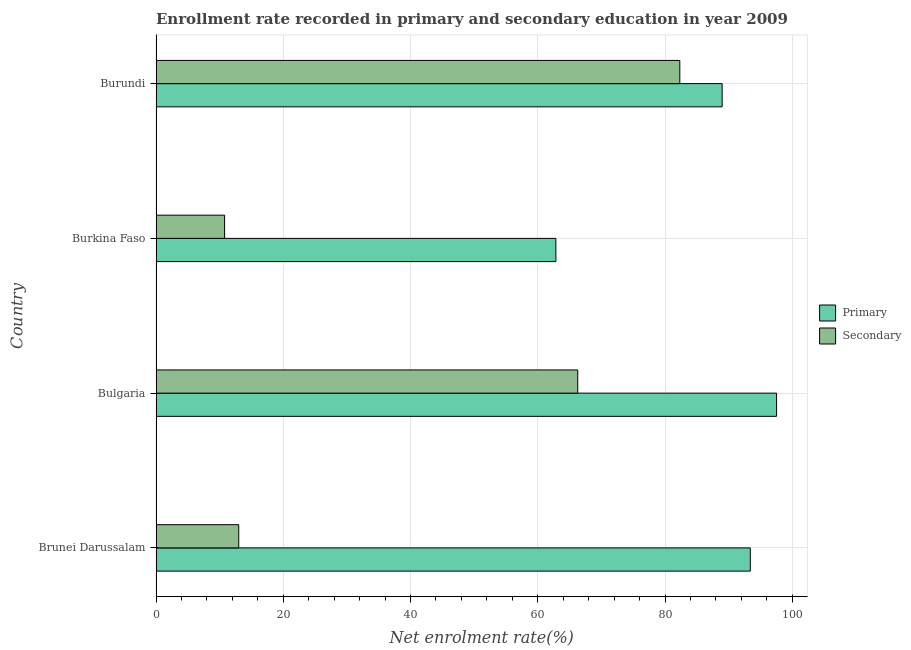How many groups of bars are there?
Ensure brevity in your answer.  4. Are the number of bars per tick equal to the number of legend labels?
Your answer should be compact. Yes. How many bars are there on the 4th tick from the top?
Provide a succinct answer. 2. What is the label of the 1st group of bars from the top?
Your answer should be very brief. Burundi. What is the enrollment rate in primary education in Burundi?
Offer a terse response. 88.98. Across all countries, what is the maximum enrollment rate in primary education?
Give a very brief answer. 97.53. Across all countries, what is the minimum enrollment rate in secondary education?
Provide a short and direct response. 10.78. In which country was the enrollment rate in primary education minimum?
Give a very brief answer. Burkina Faso. What is the total enrollment rate in secondary education in the graph?
Offer a terse response. 172.38. What is the difference between the enrollment rate in primary education in Brunei Darussalam and that in Burkina Faso?
Provide a succinct answer. 30.55. What is the difference between the enrollment rate in primary education in Burkina Faso and the enrollment rate in secondary education in Brunei Darussalam?
Provide a succinct answer. 49.84. What is the average enrollment rate in primary education per country?
Ensure brevity in your answer.  85.69. What is the difference between the enrollment rate in primary education and enrollment rate in secondary education in Burkina Faso?
Provide a succinct answer. 52.07. What is the ratio of the enrollment rate in primary education in Brunei Darussalam to that in Burundi?
Give a very brief answer. 1.05. Is the enrollment rate in secondary education in Burkina Faso less than that in Burundi?
Your answer should be very brief. Yes. Is the difference between the enrollment rate in secondary education in Burkina Faso and Burundi greater than the difference between the enrollment rate in primary education in Burkina Faso and Burundi?
Give a very brief answer. No. What is the difference between the highest and the second highest enrollment rate in primary education?
Your response must be concise. 4.13. What is the difference between the highest and the lowest enrollment rate in primary education?
Your answer should be very brief. 34.68. Is the sum of the enrollment rate in secondary education in Bulgaria and Burkina Faso greater than the maximum enrollment rate in primary education across all countries?
Your answer should be very brief. No. What does the 2nd bar from the top in Burundi represents?
Your answer should be compact. Primary. What does the 1st bar from the bottom in Bulgaria represents?
Your answer should be very brief. Primary. How many countries are there in the graph?
Your answer should be compact. 4. Are the values on the major ticks of X-axis written in scientific E-notation?
Give a very brief answer. No. Does the graph contain grids?
Ensure brevity in your answer.  Yes. Where does the legend appear in the graph?
Keep it short and to the point. Center right. How many legend labels are there?
Your answer should be very brief. 2. How are the legend labels stacked?
Offer a terse response. Vertical. What is the title of the graph?
Keep it short and to the point. Enrollment rate recorded in primary and secondary education in year 2009. What is the label or title of the X-axis?
Ensure brevity in your answer.  Net enrolment rate(%). What is the label or title of the Y-axis?
Your answer should be compact. Country. What is the Net enrolment rate(%) in Primary in Brunei Darussalam?
Make the answer very short. 93.4. What is the Net enrolment rate(%) in Secondary in Brunei Darussalam?
Ensure brevity in your answer.  13. What is the Net enrolment rate(%) of Primary in Bulgaria?
Your response must be concise. 97.53. What is the Net enrolment rate(%) in Secondary in Bulgaria?
Offer a very short reply. 66.28. What is the Net enrolment rate(%) in Primary in Burkina Faso?
Your answer should be compact. 62.85. What is the Net enrolment rate(%) in Secondary in Burkina Faso?
Ensure brevity in your answer.  10.78. What is the Net enrolment rate(%) in Primary in Burundi?
Make the answer very short. 88.98. What is the Net enrolment rate(%) of Secondary in Burundi?
Your response must be concise. 82.32. Across all countries, what is the maximum Net enrolment rate(%) of Primary?
Ensure brevity in your answer.  97.53. Across all countries, what is the maximum Net enrolment rate(%) in Secondary?
Offer a terse response. 82.32. Across all countries, what is the minimum Net enrolment rate(%) in Primary?
Your answer should be very brief. 62.85. Across all countries, what is the minimum Net enrolment rate(%) of Secondary?
Your response must be concise. 10.78. What is the total Net enrolment rate(%) of Primary in the graph?
Make the answer very short. 342.75. What is the total Net enrolment rate(%) in Secondary in the graph?
Make the answer very short. 172.38. What is the difference between the Net enrolment rate(%) in Primary in Brunei Darussalam and that in Bulgaria?
Make the answer very short. -4.13. What is the difference between the Net enrolment rate(%) in Secondary in Brunei Darussalam and that in Bulgaria?
Offer a very short reply. -53.28. What is the difference between the Net enrolment rate(%) in Primary in Brunei Darussalam and that in Burkina Faso?
Your answer should be compact. 30.55. What is the difference between the Net enrolment rate(%) in Secondary in Brunei Darussalam and that in Burkina Faso?
Your response must be concise. 2.22. What is the difference between the Net enrolment rate(%) in Primary in Brunei Darussalam and that in Burundi?
Your answer should be very brief. 4.42. What is the difference between the Net enrolment rate(%) in Secondary in Brunei Darussalam and that in Burundi?
Keep it short and to the point. -69.32. What is the difference between the Net enrolment rate(%) in Primary in Bulgaria and that in Burkina Faso?
Give a very brief answer. 34.68. What is the difference between the Net enrolment rate(%) of Secondary in Bulgaria and that in Burkina Faso?
Your answer should be very brief. 55.5. What is the difference between the Net enrolment rate(%) of Primary in Bulgaria and that in Burundi?
Make the answer very short. 8.55. What is the difference between the Net enrolment rate(%) in Secondary in Bulgaria and that in Burundi?
Provide a succinct answer. -16.04. What is the difference between the Net enrolment rate(%) in Primary in Burkina Faso and that in Burundi?
Ensure brevity in your answer.  -26.13. What is the difference between the Net enrolment rate(%) in Secondary in Burkina Faso and that in Burundi?
Ensure brevity in your answer.  -71.54. What is the difference between the Net enrolment rate(%) of Primary in Brunei Darussalam and the Net enrolment rate(%) of Secondary in Bulgaria?
Ensure brevity in your answer.  27.12. What is the difference between the Net enrolment rate(%) of Primary in Brunei Darussalam and the Net enrolment rate(%) of Secondary in Burkina Faso?
Your answer should be compact. 82.62. What is the difference between the Net enrolment rate(%) of Primary in Brunei Darussalam and the Net enrolment rate(%) of Secondary in Burundi?
Provide a succinct answer. 11.07. What is the difference between the Net enrolment rate(%) of Primary in Bulgaria and the Net enrolment rate(%) of Secondary in Burkina Faso?
Keep it short and to the point. 86.75. What is the difference between the Net enrolment rate(%) of Primary in Bulgaria and the Net enrolment rate(%) of Secondary in Burundi?
Make the answer very short. 15.21. What is the difference between the Net enrolment rate(%) in Primary in Burkina Faso and the Net enrolment rate(%) in Secondary in Burundi?
Keep it short and to the point. -19.48. What is the average Net enrolment rate(%) in Primary per country?
Give a very brief answer. 85.69. What is the average Net enrolment rate(%) in Secondary per country?
Your response must be concise. 43.1. What is the difference between the Net enrolment rate(%) in Primary and Net enrolment rate(%) in Secondary in Brunei Darussalam?
Keep it short and to the point. 80.4. What is the difference between the Net enrolment rate(%) of Primary and Net enrolment rate(%) of Secondary in Bulgaria?
Offer a terse response. 31.25. What is the difference between the Net enrolment rate(%) of Primary and Net enrolment rate(%) of Secondary in Burkina Faso?
Your response must be concise. 52.07. What is the difference between the Net enrolment rate(%) in Primary and Net enrolment rate(%) in Secondary in Burundi?
Provide a short and direct response. 6.65. What is the ratio of the Net enrolment rate(%) of Primary in Brunei Darussalam to that in Bulgaria?
Your answer should be compact. 0.96. What is the ratio of the Net enrolment rate(%) in Secondary in Brunei Darussalam to that in Bulgaria?
Your answer should be very brief. 0.2. What is the ratio of the Net enrolment rate(%) of Primary in Brunei Darussalam to that in Burkina Faso?
Give a very brief answer. 1.49. What is the ratio of the Net enrolment rate(%) of Secondary in Brunei Darussalam to that in Burkina Faso?
Provide a succinct answer. 1.21. What is the ratio of the Net enrolment rate(%) in Primary in Brunei Darussalam to that in Burundi?
Your answer should be very brief. 1.05. What is the ratio of the Net enrolment rate(%) of Secondary in Brunei Darussalam to that in Burundi?
Your response must be concise. 0.16. What is the ratio of the Net enrolment rate(%) of Primary in Bulgaria to that in Burkina Faso?
Provide a short and direct response. 1.55. What is the ratio of the Net enrolment rate(%) in Secondary in Bulgaria to that in Burkina Faso?
Ensure brevity in your answer.  6.15. What is the ratio of the Net enrolment rate(%) of Primary in Bulgaria to that in Burundi?
Your answer should be very brief. 1.1. What is the ratio of the Net enrolment rate(%) in Secondary in Bulgaria to that in Burundi?
Provide a short and direct response. 0.81. What is the ratio of the Net enrolment rate(%) of Primary in Burkina Faso to that in Burundi?
Offer a terse response. 0.71. What is the ratio of the Net enrolment rate(%) in Secondary in Burkina Faso to that in Burundi?
Give a very brief answer. 0.13. What is the difference between the highest and the second highest Net enrolment rate(%) in Primary?
Offer a very short reply. 4.13. What is the difference between the highest and the second highest Net enrolment rate(%) of Secondary?
Make the answer very short. 16.04. What is the difference between the highest and the lowest Net enrolment rate(%) of Primary?
Keep it short and to the point. 34.68. What is the difference between the highest and the lowest Net enrolment rate(%) of Secondary?
Provide a short and direct response. 71.54. 